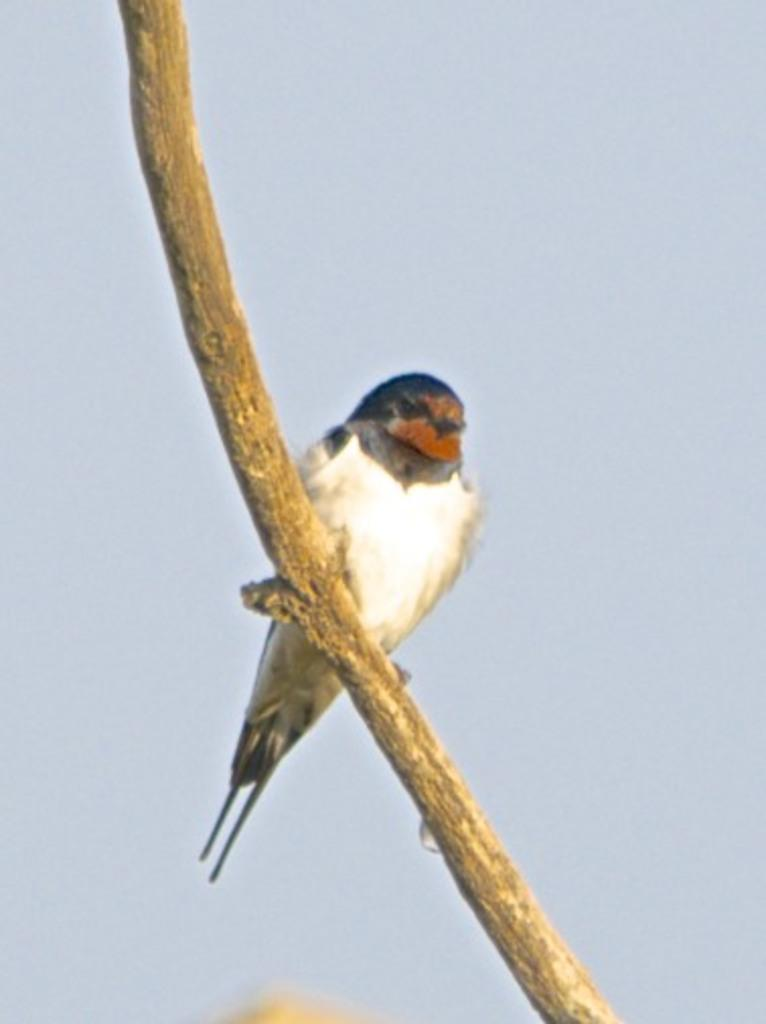What type of animal is in the image? There is a bird in the image. How is the bird positioned in the image? The bird is on a stick. What color is the background of the image? The background of the image is blue. What type of test is the bird conducting in the image? There is no test being conducted in the image; it simply shows a bird on a stick with a blue background. 